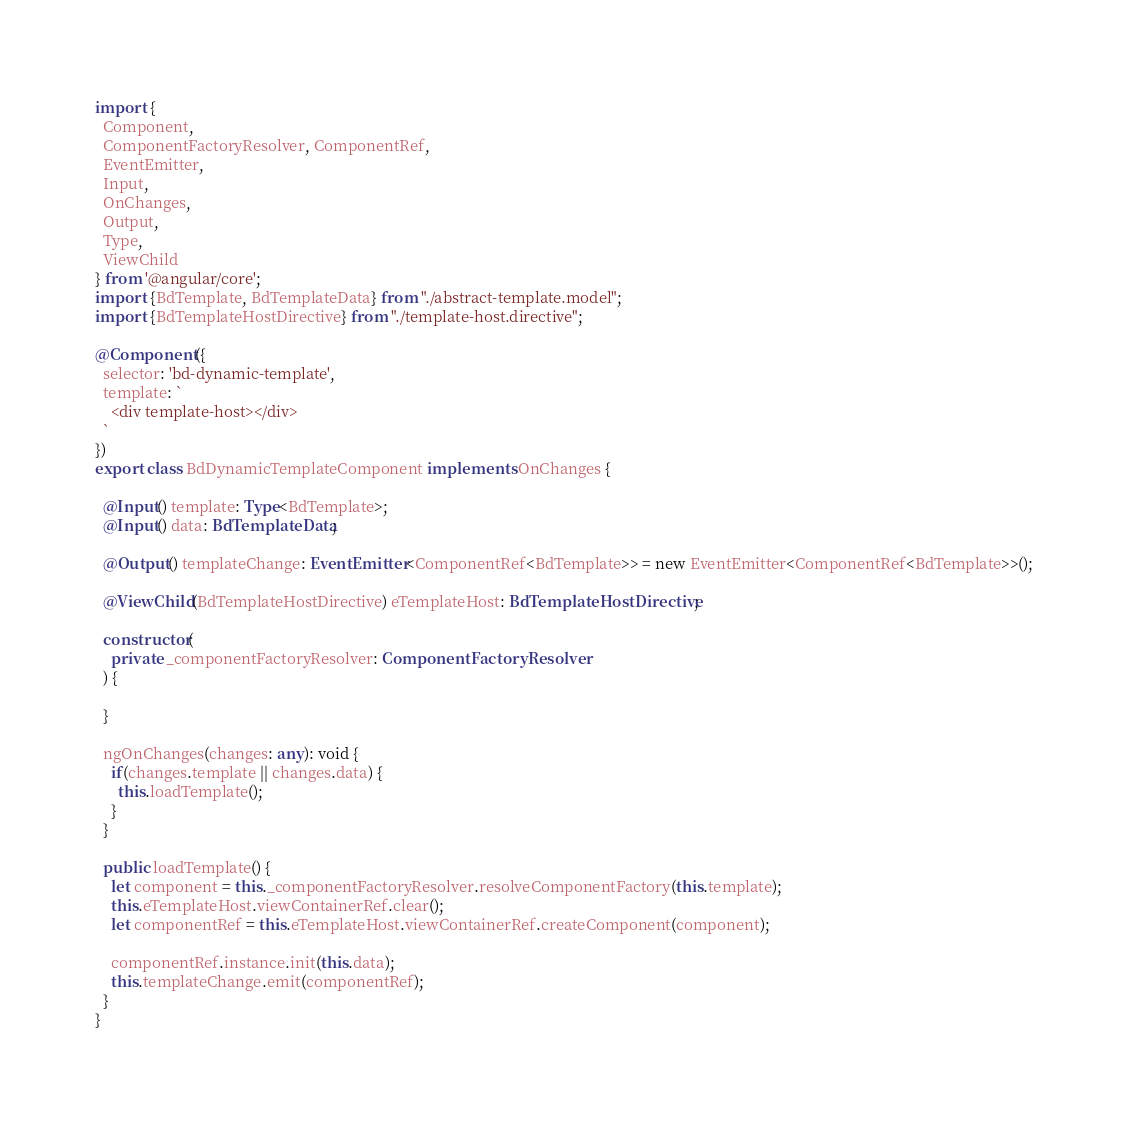Convert code to text. <code><loc_0><loc_0><loc_500><loc_500><_TypeScript_>import {
  Component,
  ComponentFactoryResolver, ComponentRef,
  EventEmitter,
  Input,
  OnChanges,
  Output,
  Type,
  ViewChild
} from '@angular/core';
import {BdTemplate, BdTemplateData} from "./abstract-template.model";
import {BdTemplateHostDirective} from "./template-host.directive";

@Component({
  selector: 'bd-dynamic-template',
  template: `
    <div template-host></div>
  `
})
export class BdDynamicTemplateComponent implements OnChanges {

  @Input() template: Type<BdTemplate>;
  @Input() data: BdTemplateData;

  @Output() templateChange: EventEmitter<ComponentRef<BdTemplate>> = new EventEmitter<ComponentRef<BdTemplate>>();

  @ViewChild(BdTemplateHostDirective) eTemplateHost: BdTemplateHostDirective;

  constructor(
    private _componentFactoryResolver: ComponentFactoryResolver
  ) {

  }

  ngOnChanges(changes: any): void {
    if(changes.template || changes.data) {
      this.loadTemplate();
    }
  }

  public loadTemplate() {
    let component = this._componentFactoryResolver.resolveComponentFactory(this.template);
    this.eTemplateHost.viewContainerRef.clear();
    let componentRef = this.eTemplateHost.viewContainerRef.createComponent(component);

    componentRef.instance.init(this.data);
    this.templateChange.emit(componentRef);
  }
}
</code> 